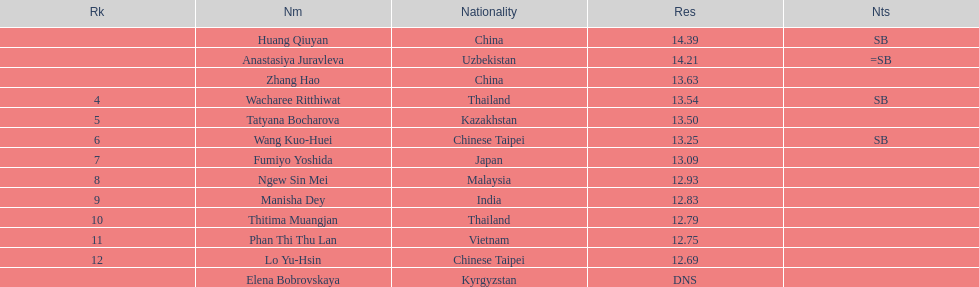How many competitors had less than 13.00 points? 6. 